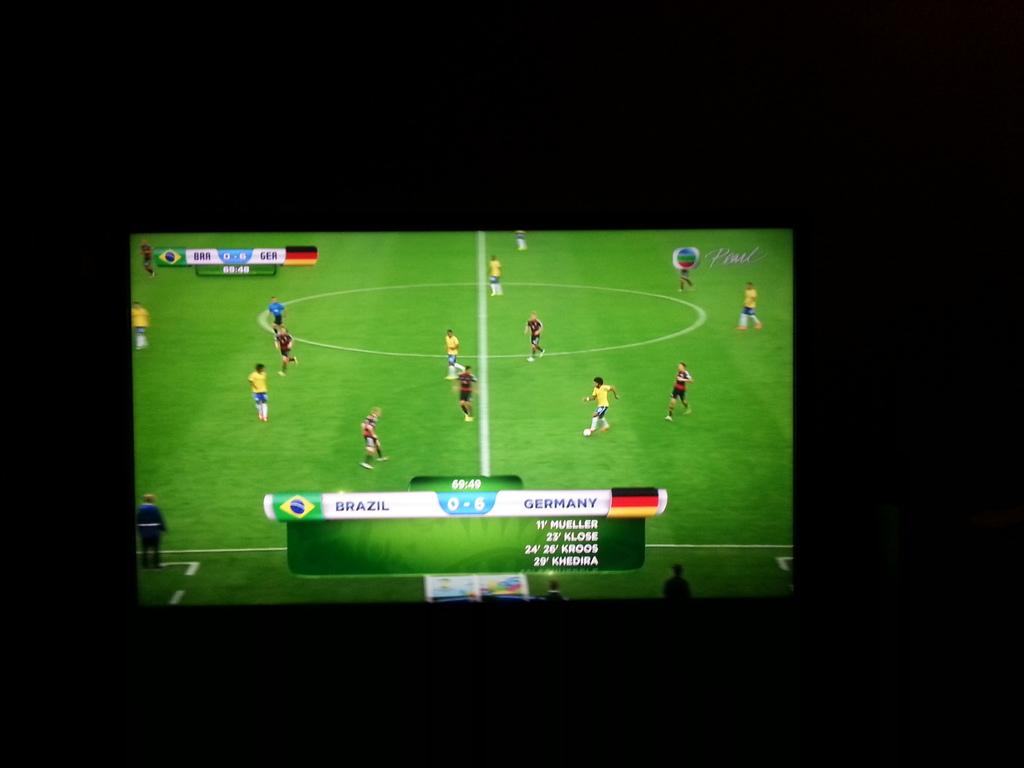What is the score?
Offer a terse response. 0-6. 